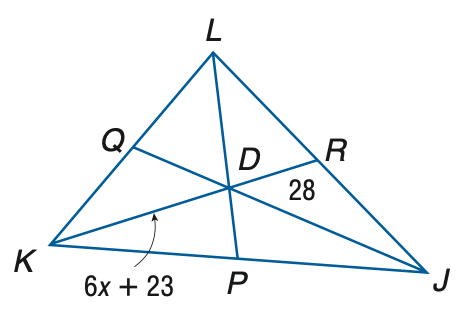Answer the mathemtical geometry problem and directly provide the correct option letter.
Question: Points P, Q, and R are the midpoints of J K, K L, and J L, respectively. Find x.
Choices: A: 0.83 B: 1.1 C: 2.0 D: 5.5 D 